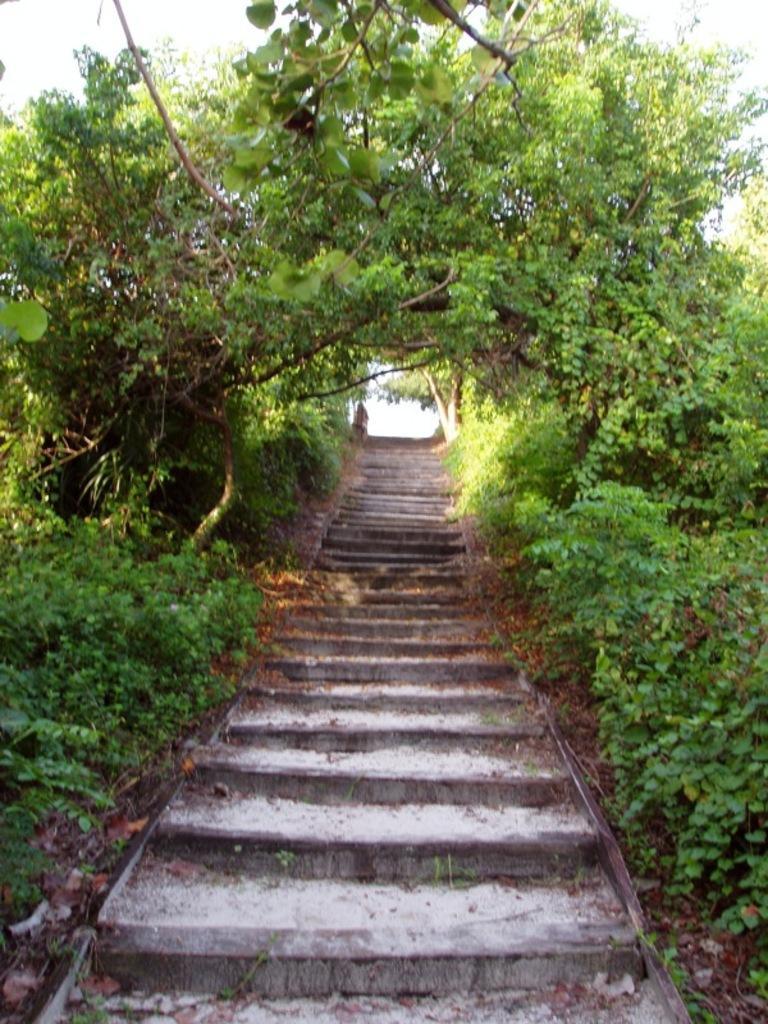In one or two sentences, can you explain what this image depicts? In this image I can see steps, plants and the sky in the background. 